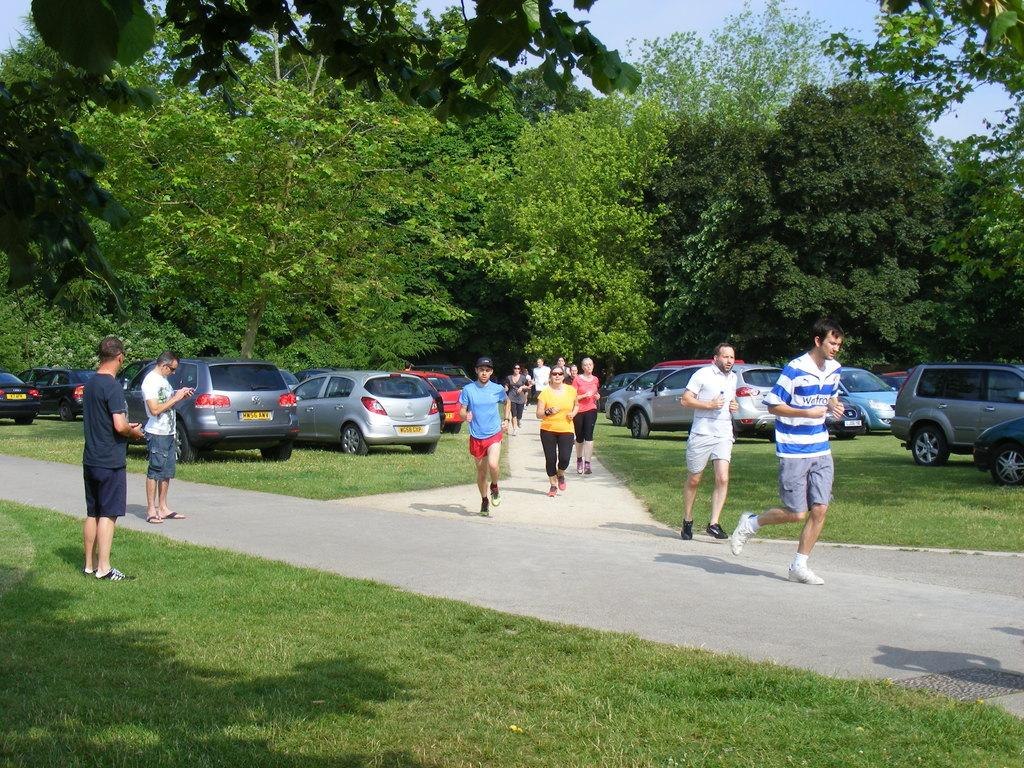How many people are in the image? There are people in the image, but the exact number is not specified. What are some of the people doing in the image? Some people are standing, and some are running on the road. What can be seen in the background of the image? There are vehicles, grass, trees, and the sky visible in the background of the image. What type of square is visible in the image? There is no square present in the image. Can you see a knife being used by any of the people in the image? There is no knife visible in the image. 